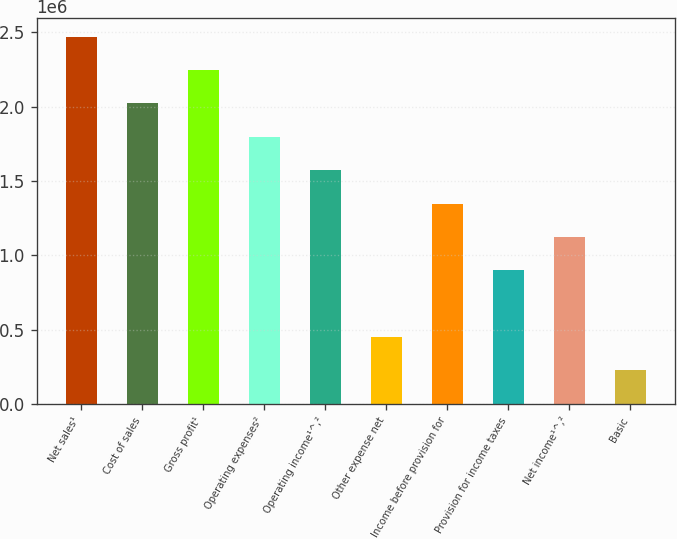Convert chart to OTSL. <chart><loc_0><loc_0><loc_500><loc_500><bar_chart><fcel>Net sales¹<fcel>Cost of sales<fcel>Gross profit¹<fcel>Operating expenses²<fcel>Operating income¹^‚²<fcel>Other expense net<fcel>Income before provision for<fcel>Provision for income taxes<fcel>Net income¹^‚²<fcel>Basic<nl><fcel>2.47107e+06<fcel>2.02179e+06<fcel>2.24643e+06<fcel>1.79714e+06<fcel>1.5725e+06<fcel>449287<fcel>1.34786e+06<fcel>898572<fcel>1.12321e+06<fcel>224645<nl></chart> 